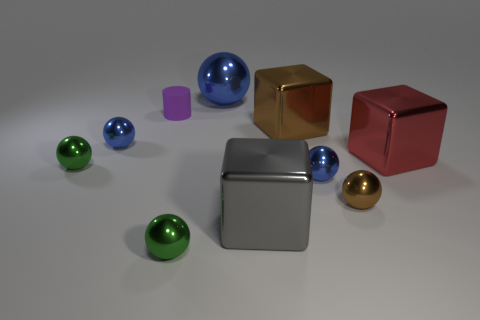How many blue balls must be subtracted to get 1 blue balls? 2 Subtract all brown shiny spheres. How many spheres are left? 5 Subtract all blue balls. How many balls are left? 3 Subtract all purple cylinders. How many brown balls are left? 1 Subtract all cylinders. How many objects are left? 9 Subtract 1 spheres. How many spheres are left? 5 Subtract all green balls. Subtract all purple cubes. How many balls are left? 4 Subtract all purple matte cylinders. Subtract all brown shiny things. How many objects are left? 7 Add 4 large red metal cubes. How many large red metal cubes are left? 5 Add 8 big yellow metal things. How many big yellow metal things exist? 8 